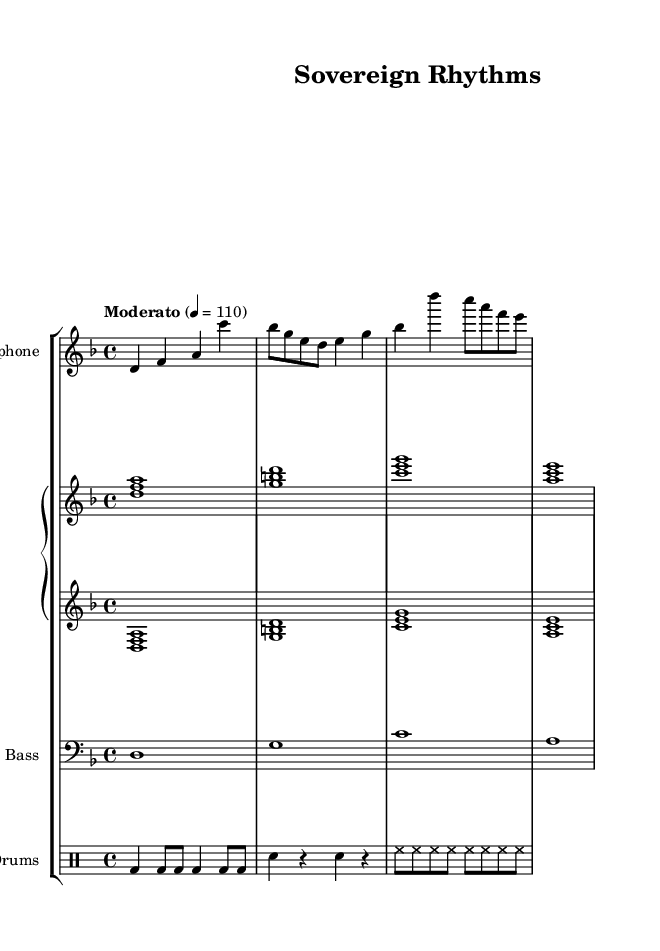What is the key signature of this music? The key signature indicates that the piece is in D minor, which typically has one flat (B flat). This can be identified by looking at the key signature shown at the beginning of the staff, which has one flat note.
Answer: D minor What is the time signature of this music? The time signature is 4/4, which means there are four beats in each measure and the quarter note gets one beat. This is visible in the numerator and denominator following the time signature notation at the beginning of the score.
Answer: 4/4 What is the tempo marking indicated for this piece? The tempo marking is marked as "Moderato" with a tempo of 110 beats per minute. This can be found explicitly in the tempo indication within the score.
Answer: Moderato, 110 How many measures are present in the saxophone part? The saxophone part has a total of four measures, which can be counted by looking at the horizontal divisions in the staff where each measure is notated.
Answer: Four What is the instrumentation of this piece? The instrumentation includes saxophone, piano, bass, and drums. This is determined by examining the staff labels and names provided at the beginning of each part in the music sheet.
Answer: Saxophone, piano, bass, drums What is the rhythmic pattern of the drum section? The drum section features a combination of bass drum hits (bd), snare hits (sn), and hi-hat patterns (hh) across its measures, reflecting common jazz drum patterns. This is established by looking at the notation used in the drum staff section.
Answer: Bass, snare, hi-hat 